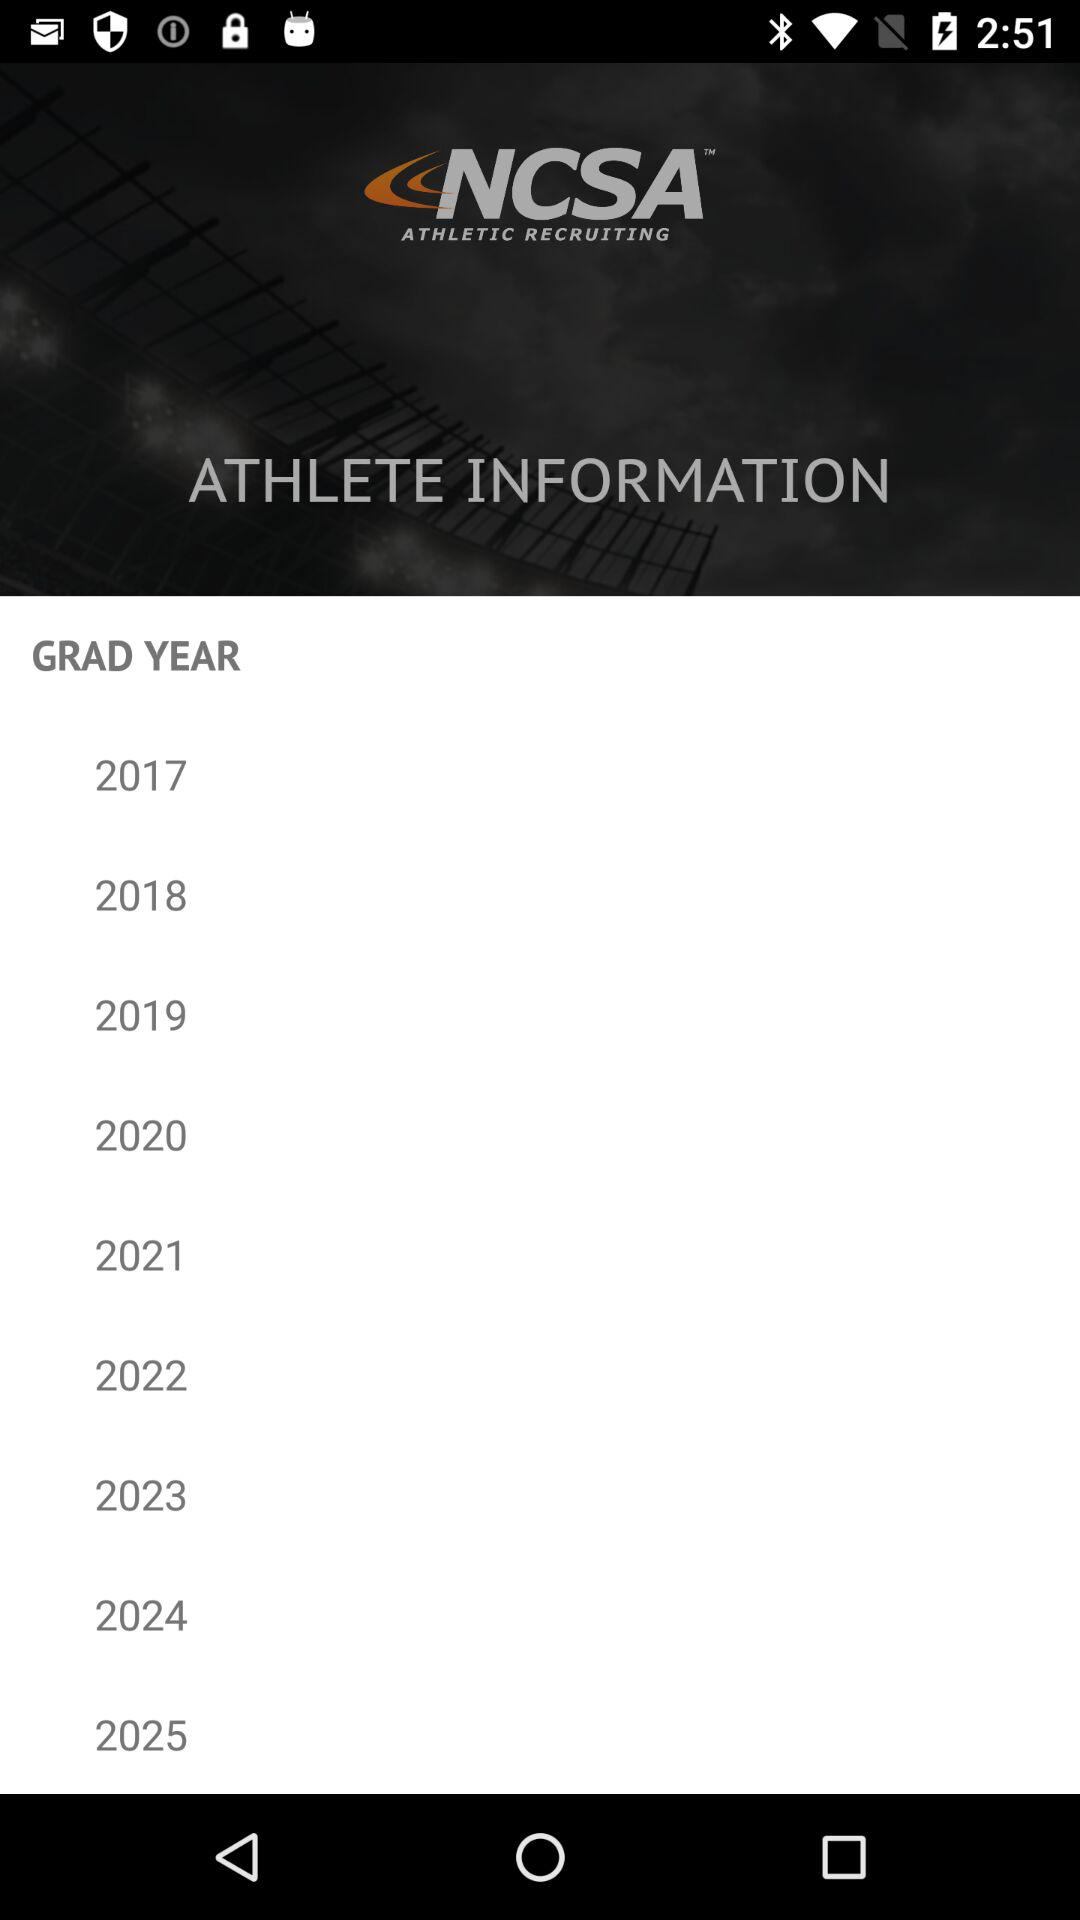What is the application name? The application name is "NCSA ATHLETIC RECRUITING". 